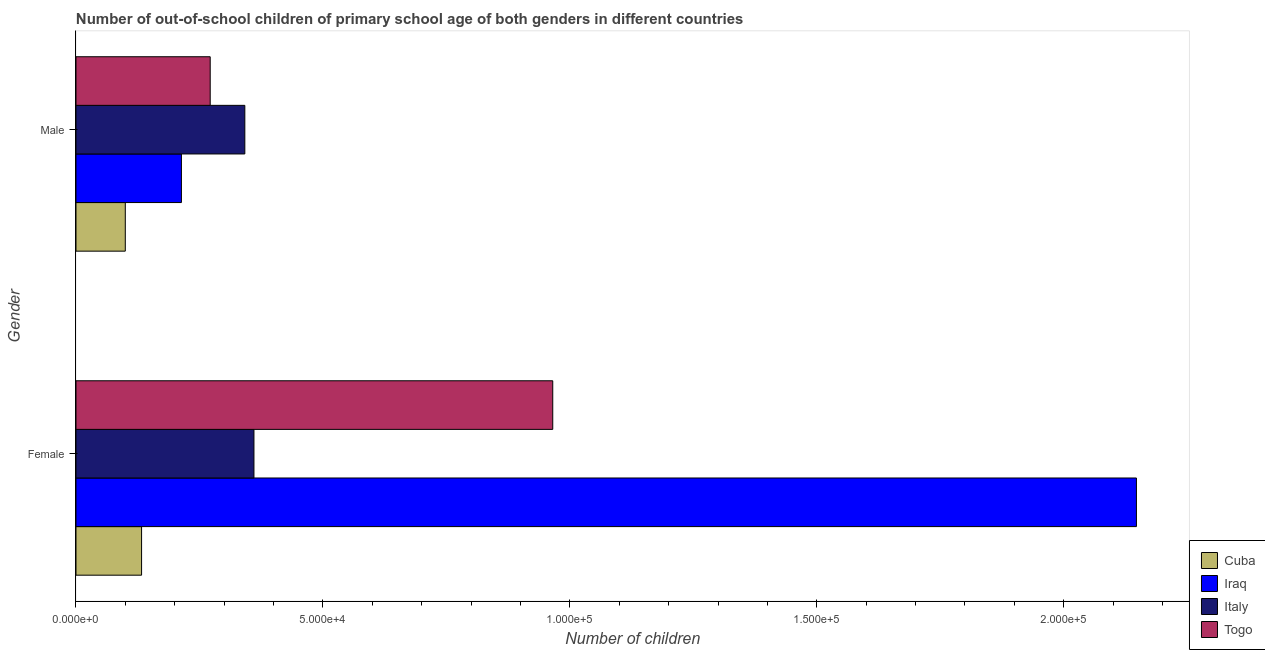How many groups of bars are there?
Keep it short and to the point. 2. Are the number of bars on each tick of the Y-axis equal?
Make the answer very short. Yes. What is the number of male out-of-school students in Italy?
Give a very brief answer. 3.42e+04. Across all countries, what is the maximum number of male out-of-school students?
Provide a short and direct response. 3.42e+04. Across all countries, what is the minimum number of male out-of-school students?
Offer a very short reply. 9983. In which country was the number of female out-of-school students maximum?
Your response must be concise. Iraq. In which country was the number of male out-of-school students minimum?
Your response must be concise. Cuba. What is the total number of female out-of-school students in the graph?
Offer a very short reply. 3.61e+05. What is the difference between the number of female out-of-school students in Cuba and that in Italy?
Offer a very short reply. -2.28e+04. What is the difference between the number of male out-of-school students in Togo and the number of female out-of-school students in Cuba?
Give a very brief answer. 1.39e+04. What is the average number of male out-of-school students per country?
Your response must be concise. 2.32e+04. What is the difference between the number of female out-of-school students and number of male out-of-school students in Cuba?
Provide a succinct answer. 3296. What is the ratio of the number of female out-of-school students in Togo to that in Italy?
Your response must be concise. 2.68. Is the number of male out-of-school students in Togo less than that in Cuba?
Your response must be concise. No. What does the 4th bar from the top in Male represents?
Ensure brevity in your answer.  Cuba. What does the 3rd bar from the bottom in Male represents?
Offer a terse response. Italy. How many bars are there?
Your answer should be compact. 8. Are all the bars in the graph horizontal?
Offer a terse response. Yes. What is the difference between two consecutive major ticks on the X-axis?
Offer a very short reply. 5.00e+04. Are the values on the major ticks of X-axis written in scientific E-notation?
Keep it short and to the point. Yes. Does the graph contain grids?
Your answer should be compact. No. What is the title of the graph?
Provide a succinct answer. Number of out-of-school children of primary school age of both genders in different countries. What is the label or title of the X-axis?
Make the answer very short. Number of children. What is the Number of children of Cuba in Female?
Provide a succinct answer. 1.33e+04. What is the Number of children in Iraq in Female?
Provide a short and direct response. 2.15e+05. What is the Number of children in Italy in Female?
Ensure brevity in your answer.  3.60e+04. What is the Number of children in Togo in Female?
Your response must be concise. 9.65e+04. What is the Number of children of Cuba in Male?
Offer a very short reply. 9983. What is the Number of children of Iraq in Male?
Make the answer very short. 2.13e+04. What is the Number of children of Italy in Male?
Offer a very short reply. 3.42e+04. What is the Number of children of Togo in Male?
Offer a terse response. 2.72e+04. Across all Gender, what is the maximum Number of children of Cuba?
Your answer should be compact. 1.33e+04. Across all Gender, what is the maximum Number of children in Iraq?
Your answer should be compact. 2.15e+05. Across all Gender, what is the maximum Number of children in Italy?
Offer a terse response. 3.60e+04. Across all Gender, what is the maximum Number of children of Togo?
Your response must be concise. 9.65e+04. Across all Gender, what is the minimum Number of children in Cuba?
Make the answer very short. 9983. Across all Gender, what is the minimum Number of children of Iraq?
Give a very brief answer. 2.13e+04. Across all Gender, what is the minimum Number of children in Italy?
Offer a terse response. 3.42e+04. Across all Gender, what is the minimum Number of children in Togo?
Offer a terse response. 2.72e+04. What is the total Number of children of Cuba in the graph?
Your answer should be very brief. 2.33e+04. What is the total Number of children of Iraq in the graph?
Make the answer very short. 2.36e+05. What is the total Number of children in Italy in the graph?
Your response must be concise. 7.02e+04. What is the total Number of children in Togo in the graph?
Keep it short and to the point. 1.24e+05. What is the difference between the Number of children in Cuba in Female and that in Male?
Provide a succinct answer. 3296. What is the difference between the Number of children of Iraq in Female and that in Male?
Keep it short and to the point. 1.93e+05. What is the difference between the Number of children in Italy in Female and that in Male?
Provide a short and direct response. 1849. What is the difference between the Number of children in Togo in Female and that in Male?
Make the answer very short. 6.94e+04. What is the difference between the Number of children of Cuba in Female and the Number of children of Iraq in Male?
Offer a very short reply. -8069. What is the difference between the Number of children of Cuba in Female and the Number of children of Italy in Male?
Your answer should be very brief. -2.09e+04. What is the difference between the Number of children of Cuba in Female and the Number of children of Togo in Male?
Ensure brevity in your answer.  -1.39e+04. What is the difference between the Number of children of Iraq in Female and the Number of children of Italy in Male?
Provide a short and direct response. 1.81e+05. What is the difference between the Number of children in Iraq in Female and the Number of children in Togo in Male?
Your answer should be compact. 1.88e+05. What is the difference between the Number of children in Italy in Female and the Number of children in Togo in Male?
Offer a very short reply. 8857. What is the average Number of children of Cuba per Gender?
Ensure brevity in your answer.  1.16e+04. What is the average Number of children of Iraq per Gender?
Offer a terse response. 1.18e+05. What is the average Number of children of Italy per Gender?
Provide a succinct answer. 3.51e+04. What is the average Number of children in Togo per Gender?
Give a very brief answer. 6.19e+04. What is the difference between the Number of children of Cuba and Number of children of Iraq in Female?
Provide a succinct answer. -2.01e+05. What is the difference between the Number of children in Cuba and Number of children in Italy in Female?
Give a very brief answer. -2.28e+04. What is the difference between the Number of children in Cuba and Number of children in Togo in Female?
Ensure brevity in your answer.  -8.33e+04. What is the difference between the Number of children of Iraq and Number of children of Italy in Female?
Your answer should be compact. 1.79e+05. What is the difference between the Number of children of Iraq and Number of children of Togo in Female?
Provide a short and direct response. 1.18e+05. What is the difference between the Number of children of Italy and Number of children of Togo in Female?
Keep it short and to the point. -6.05e+04. What is the difference between the Number of children of Cuba and Number of children of Iraq in Male?
Your response must be concise. -1.14e+04. What is the difference between the Number of children in Cuba and Number of children in Italy in Male?
Provide a succinct answer. -2.42e+04. What is the difference between the Number of children in Cuba and Number of children in Togo in Male?
Your answer should be very brief. -1.72e+04. What is the difference between the Number of children of Iraq and Number of children of Italy in Male?
Ensure brevity in your answer.  -1.28e+04. What is the difference between the Number of children of Iraq and Number of children of Togo in Male?
Ensure brevity in your answer.  -5828. What is the difference between the Number of children in Italy and Number of children in Togo in Male?
Provide a short and direct response. 7008. What is the ratio of the Number of children of Cuba in Female to that in Male?
Your answer should be compact. 1.33. What is the ratio of the Number of children in Iraq in Female to that in Male?
Make the answer very short. 10.06. What is the ratio of the Number of children in Italy in Female to that in Male?
Give a very brief answer. 1.05. What is the ratio of the Number of children in Togo in Female to that in Male?
Ensure brevity in your answer.  3.55. What is the difference between the highest and the second highest Number of children of Cuba?
Provide a short and direct response. 3296. What is the difference between the highest and the second highest Number of children of Iraq?
Your answer should be compact. 1.93e+05. What is the difference between the highest and the second highest Number of children in Italy?
Provide a succinct answer. 1849. What is the difference between the highest and the second highest Number of children of Togo?
Your answer should be very brief. 6.94e+04. What is the difference between the highest and the lowest Number of children of Cuba?
Ensure brevity in your answer.  3296. What is the difference between the highest and the lowest Number of children of Iraq?
Make the answer very short. 1.93e+05. What is the difference between the highest and the lowest Number of children in Italy?
Give a very brief answer. 1849. What is the difference between the highest and the lowest Number of children of Togo?
Provide a succinct answer. 6.94e+04. 